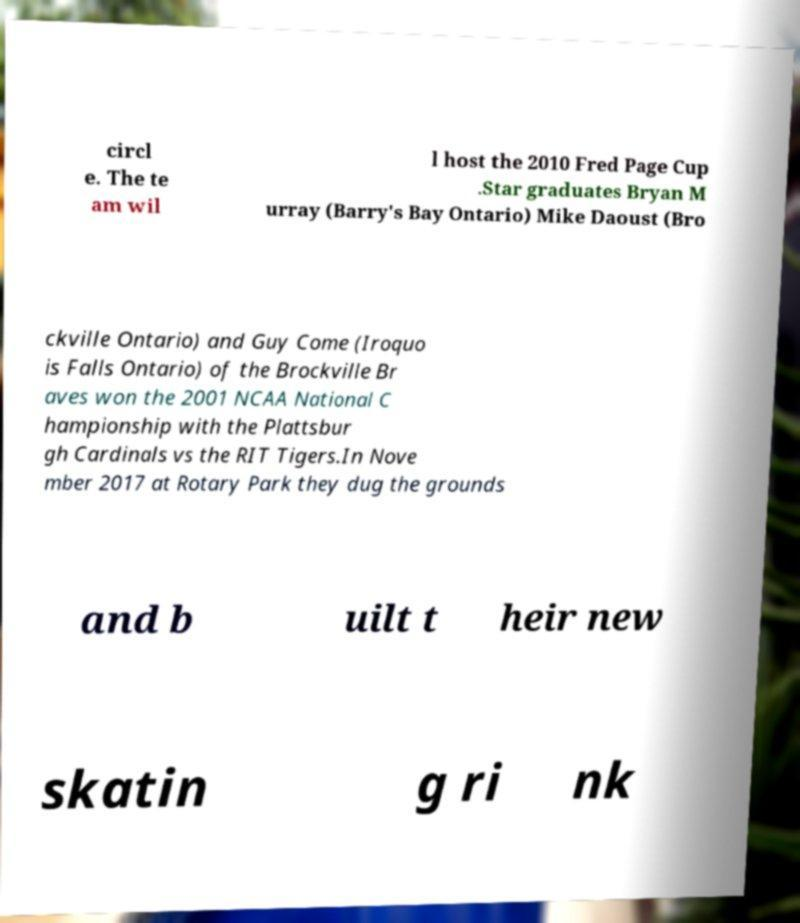Can you read and provide the text displayed in the image?This photo seems to have some interesting text. Can you extract and type it out for me? circl e. The te am wil l host the 2010 Fred Page Cup .Star graduates Bryan M urray (Barry's Bay Ontario) Mike Daoust (Bro ckville Ontario) and Guy Come (Iroquo is Falls Ontario) of the Brockville Br aves won the 2001 NCAA National C hampionship with the Plattsbur gh Cardinals vs the RIT Tigers.In Nove mber 2017 at Rotary Park they dug the grounds and b uilt t heir new skatin g ri nk 